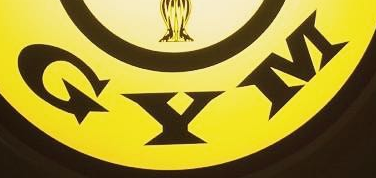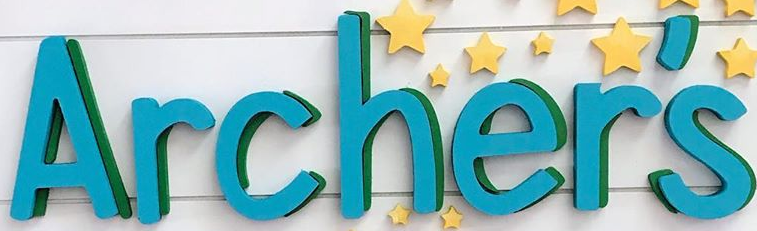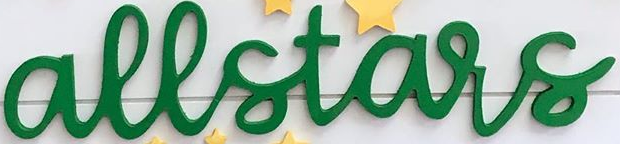Read the text content from these images in order, separated by a semicolon. GYM; Archer's; allstars 